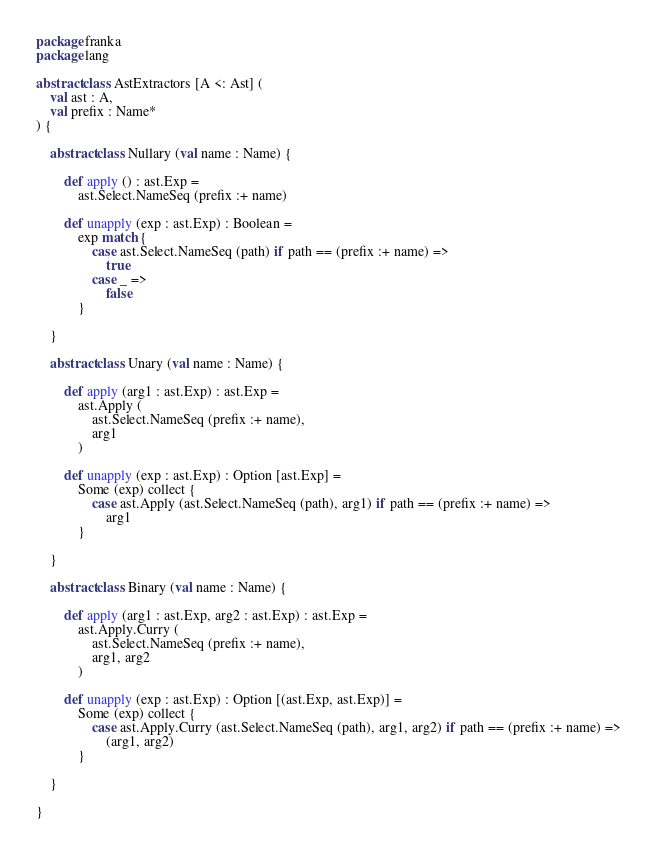Convert code to text. <code><loc_0><loc_0><loc_500><loc_500><_Scala_>package franka
package lang

abstract class AstExtractors [A <: Ast] (
    val ast : A,
    val prefix : Name*
) {

    abstract class Nullary (val name : Name) {

        def apply () : ast.Exp =
            ast.Select.NameSeq (prefix :+ name)

        def unapply (exp : ast.Exp) : Boolean =
            exp match {
                case ast.Select.NameSeq (path) if path == (prefix :+ name) =>
                    true
                case _ =>
                    false
            }

    }

    abstract class Unary (val name : Name) {

        def apply (arg1 : ast.Exp) : ast.Exp =
            ast.Apply (
                ast.Select.NameSeq (prefix :+ name),
                arg1
            )

        def unapply (exp : ast.Exp) : Option [ast.Exp] =
            Some (exp) collect {
                case ast.Apply (ast.Select.NameSeq (path), arg1) if path == (prefix :+ name) =>
                    arg1
            }

    }

    abstract class Binary (val name : Name) {

        def apply (arg1 : ast.Exp, arg2 : ast.Exp) : ast.Exp =
            ast.Apply.Curry (
                ast.Select.NameSeq (prefix :+ name),
                arg1, arg2
            )

        def unapply (exp : ast.Exp) : Option [(ast.Exp, ast.Exp)] =
            Some (exp) collect {
                case ast.Apply.Curry (ast.Select.NameSeq (path), arg1, arg2) if path == (prefix :+ name) =>
                    (arg1, arg2)
            }

    }

}
</code> 